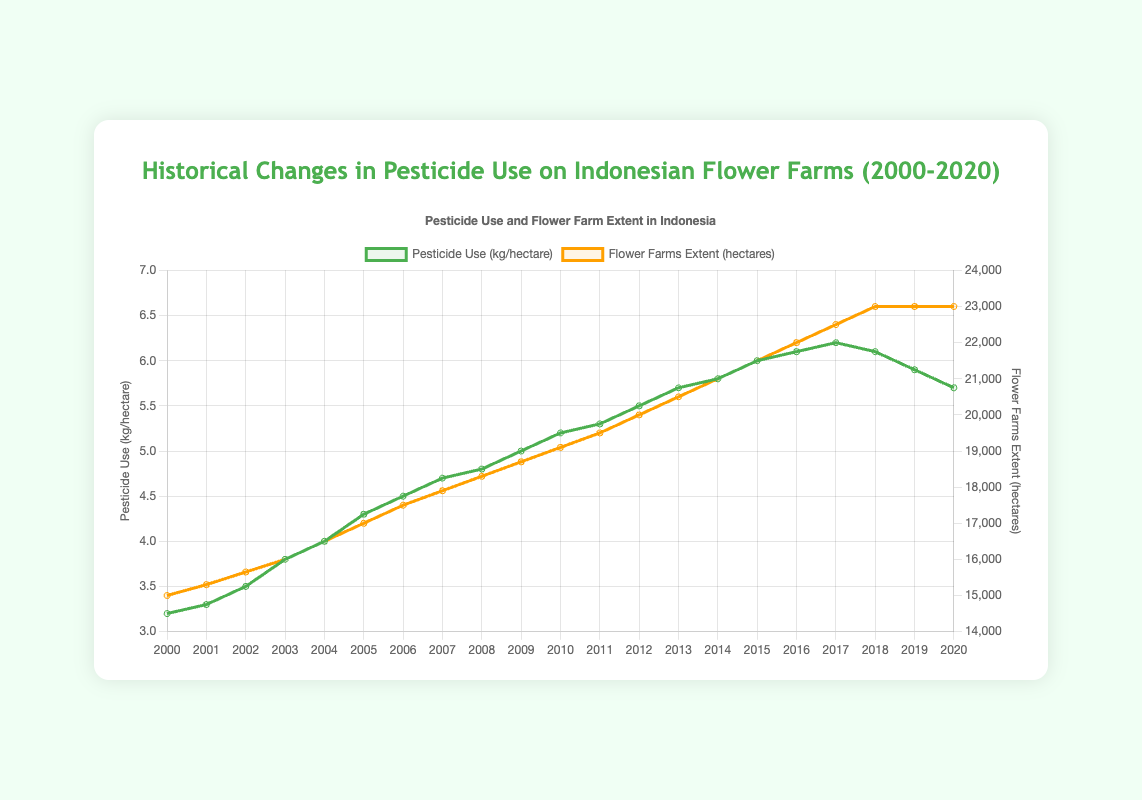What was the pesticide use in kg/hectare in 2000? Refer to the line plot and locate the data point for the year 2000 on the 'Pesticide Use' line.
Answer: 3.2 Which year had the highest pesticide use, and what was its value? Identify the peak point on the 'Pesticide Use' line and match it to the corresponding year.
Answer: 2017, 6.2 How did the flower farms extent in hectares change from 2000 to 2020? Compare the starting value (2000) and ending value (2020) of the 'Flower Farms Extent' line.
Answer: Increased from 15000 to 23000 hectares What is the difference in pesticide use between 2005 and 2020? Subtract the value for 2020 from the value for 2005 using the 'Pesticide Use' line.
Answer: 0.4 kg/hectare In which year did the flower farms extent first reach 20,000 hectares? Find the first point where the 'Flower Farms Extent' line crosses or reaches 20,000 hectares.
Answer: 2012 When did the pesticide use plateau or start to decline? Observe the 'Pesticide Use' line and note the year when it either flattened or started to decrease.
Answer: After 2017 What is the average increase in flower farms extent per year from 2000 to 2010? Calculate the total increase in flower farms extent over 10 years and divide by 10. (19100 - 15000) / 10 = 410 hectares per year.
Answer: 410 hectares per year Compare the increase in pesticide use to the increase in flower farms extent between 2005 and 2010. Subtract the 2005 values from 2010 values for both metrics and compare: Pesticide Use: (5.2 - 4.3), Flower Farms Extent: (19100 - 17000).
Answer: Pesticide Use increased by 0.9 kg/hectare, Flower Farms Extent increased by 2100 hectares Which notable flower farm was not listed in 2015 but listed in 2000? Identify the notable flower farms for both years and find the one that was removed.
Answer: Cihideung Flower Village What patterns do you observe in the correlation between pesticide use and flower farms extent over the years? Analyze the trends of both lines: a general parallel increase until 2017, where pesticide use starts to level off or decline despite a continued increase in flower farms extent.
Answer: Both tend to increase together till 2017, after which pesticide use stabilizes or declines 